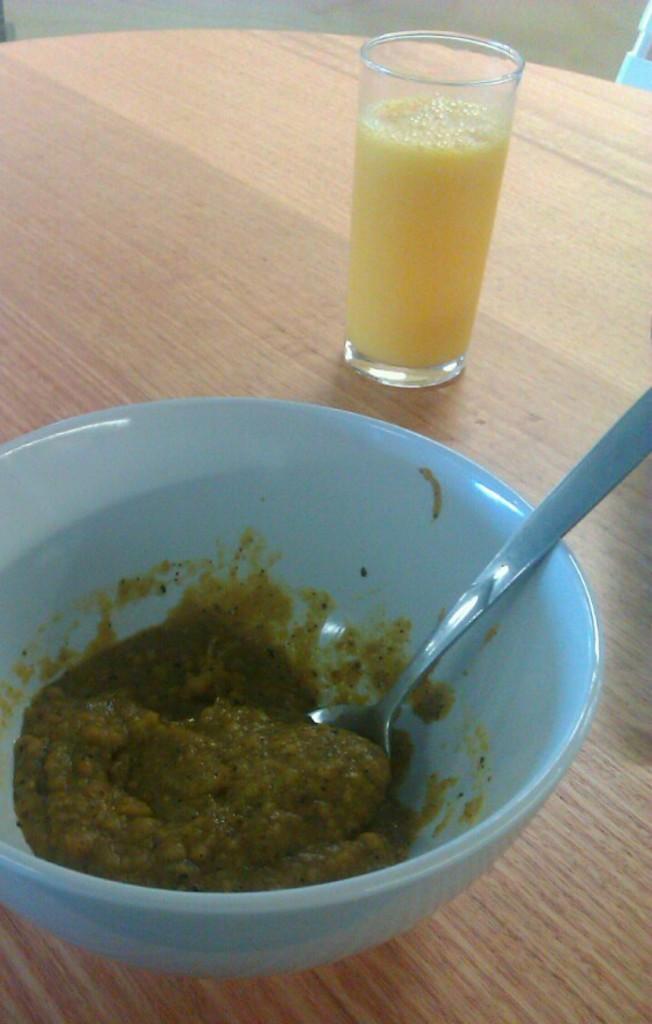Can you describe this image briefly? This image consists of a bowl in blue color along with a spoon in which there is food. Beside that, there is a glass of juice are kept on a table made up of wood. At the bottom, we can see the floor. 